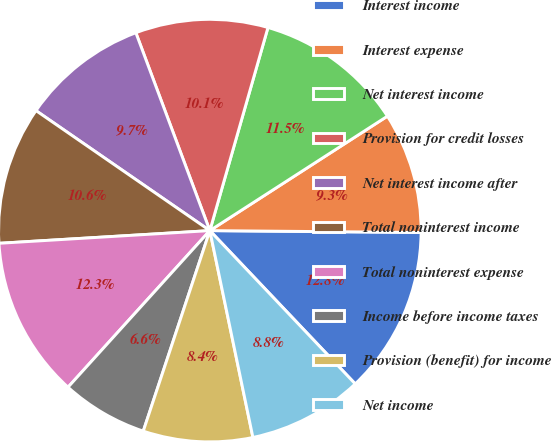Convert chart to OTSL. <chart><loc_0><loc_0><loc_500><loc_500><pie_chart><fcel>Interest income<fcel>Interest expense<fcel>Net interest income<fcel>Provision for credit losses<fcel>Net interest income after<fcel>Total noninterest income<fcel>Total noninterest expense<fcel>Income before income taxes<fcel>Provision (benefit) for income<fcel>Net income<nl><fcel>12.78%<fcel>9.25%<fcel>11.45%<fcel>10.13%<fcel>9.69%<fcel>10.57%<fcel>12.33%<fcel>6.61%<fcel>8.37%<fcel>8.81%<nl></chart> 